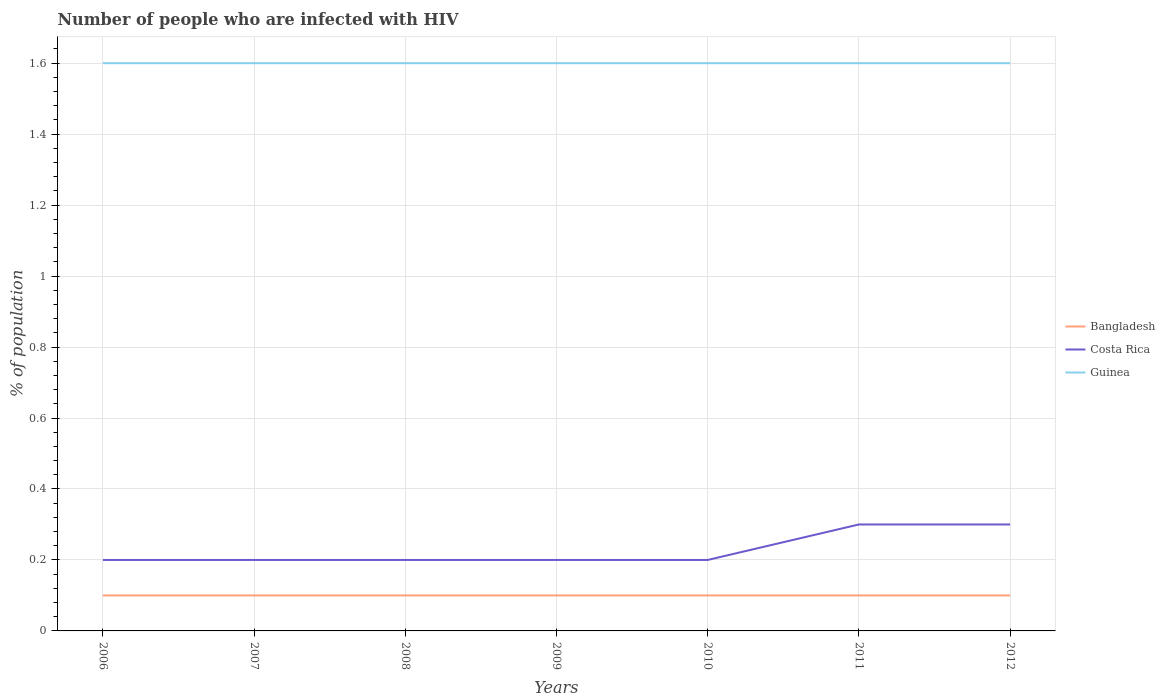How many different coloured lines are there?
Offer a terse response. 3. Across all years, what is the maximum percentage of HIV infected population in in Bangladesh?
Provide a succinct answer. 0.1. In which year was the percentage of HIV infected population in in Bangladesh maximum?
Your answer should be very brief. 2006. What is the difference between the highest and the lowest percentage of HIV infected population in in Bangladesh?
Your answer should be very brief. 7. How many lines are there?
Your answer should be very brief. 3. How many years are there in the graph?
Your response must be concise. 7. Does the graph contain any zero values?
Keep it short and to the point. No. Does the graph contain grids?
Your answer should be very brief. Yes. How many legend labels are there?
Ensure brevity in your answer.  3. What is the title of the graph?
Make the answer very short. Number of people who are infected with HIV. What is the label or title of the Y-axis?
Your answer should be very brief. % of population. What is the % of population of Bangladesh in 2006?
Make the answer very short. 0.1. What is the % of population of Costa Rica in 2006?
Make the answer very short. 0.2. What is the % of population of Guinea in 2006?
Your answer should be compact. 1.6. What is the % of population of Bangladesh in 2007?
Your response must be concise. 0.1. What is the % of population of Guinea in 2007?
Keep it short and to the point. 1.6. What is the % of population in Guinea in 2009?
Your response must be concise. 1.6. What is the % of population in Guinea in 2010?
Your answer should be very brief. 1.6. What is the % of population in Costa Rica in 2011?
Your answer should be compact. 0.3. Across all years, what is the maximum % of population in Costa Rica?
Provide a short and direct response. 0.3. Across all years, what is the maximum % of population of Guinea?
Provide a short and direct response. 1.6. Across all years, what is the minimum % of population in Bangladesh?
Keep it short and to the point. 0.1. Across all years, what is the minimum % of population in Guinea?
Your answer should be very brief. 1.6. What is the total % of population of Costa Rica in the graph?
Provide a short and direct response. 1.6. What is the difference between the % of population of Bangladesh in 2006 and that in 2007?
Ensure brevity in your answer.  0. What is the difference between the % of population of Bangladesh in 2006 and that in 2008?
Ensure brevity in your answer.  0. What is the difference between the % of population of Bangladesh in 2006 and that in 2009?
Provide a short and direct response. 0. What is the difference between the % of population of Guinea in 2006 and that in 2009?
Give a very brief answer. 0. What is the difference between the % of population in Bangladesh in 2006 and that in 2010?
Provide a succinct answer. 0. What is the difference between the % of population in Bangladesh in 2006 and that in 2011?
Ensure brevity in your answer.  0. What is the difference between the % of population in Bangladesh in 2006 and that in 2012?
Offer a terse response. 0. What is the difference between the % of population of Costa Rica in 2006 and that in 2012?
Keep it short and to the point. -0.1. What is the difference between the % of population in Costa Rica in 2007 and that in 2008?
Your answer should be very brief. 0. What is the difference between the % of population in Bangladesh in 2007 and that in 2009?
Your response must be concise. 0. What is the difference between the % of population of Costa Rica in 2007 and that in 2009?
Your response must be concise. 0. What is the difference between the % of population of Costa Rica in 2007 and that in 2010?
Your answer should be compact. 0. What is the difference between the % of population in Guinea in 2007 and that in 2010?
Offer a terse response. 0. What is the difference between the % of population of Bangladesh in 2007 and that in 2012?
Offer a terse response. 0. What is the difference between the % of population in Bangladesh in 2008 and that in 2009?
Your answer should be very brief. 0. What is the difference between the % of population in Costa Rica in 2008 and that in 2009?
Make the answer very short. 0. What is the difference between the % of population in Costa Rica in 2008 and that in 2010?
Give a very brief answer. 0. What is the difference between the % of population of Guinea in 2008 and that in 2010?
Make the answer very short. 0. What is the difference between the % of population of Costa Rica in 2008 and that in 2011?
Provide a short and direct response. -0.1. What is the difference between the % of population of Costa Rica in 2008 and that in 2012?
Your answer should be compact. -0.1. What is the difference between the % of population in Costa Rica in 2009 and that in 2010?
Make the answer very short. 0. What is the difference between the % of population of Guinea in 2009 and that in 2011?
Your response must be concise. 0. What is the difference between the % of population of Costa Rica in 2009 and that in 2012?
Your answer should be compact. -0.1. What is the difference between the % of population in Guinea in 2009 and that in 2012?
Your answer should be very brief. 0. What is the difference between the % of population of Bangladesh in 2010 and that in 2011?
Provide a succinct answer. 0. What is the difference between the % of population in Costa Rica in 2010 and that in 2011?
Offer a terse response. -0.1. What is the difference between the % of population of Bangladesh in 2010 and that in 2012?
Provide a short and direct response. 0. What is the difference between the % of population of Costa Rica in 2010 and that in 2012?
Provide a succinct answer. -0.1. What is the difference between the % of population of Bangladesh in 2011 and that in 2012?
Offer a very short reply. 0. What is the difference between the % of population of Costa Rica in 2011 and that in 2012?
Make the answer very short. 0. What is the difference between the % of population of Guinea in 2011 and that in 2012?
Make the answer very short. 0. What is the difference between the % of population in Bangladesh in 2006 and the % of population in Guinea in 2007?
Offer a terse response. -1.5. What is the difference between the % of population of Costa Rica in 2006 and the % of population of Guinea in 2007?
Give a very brief answer. -1.4. What is the difference between the % of population of Bangladesh in 2006 and the % of population of Guinea in 2008?
Your answer should be very brief. -1.5. What is the difference between the % of population in Costa Rica in 2006 and the % of population in Guinea in 2008?
Offer a very short reply. -1.4. What is the difference between the % of population in Bangladesh in 2006 and the % of population in Guinea in 2009?
Give a very brief answer. -1.5. What is the difference between the % of population in Bangladesh in 2006 and the % of population in Costa Rica in 2011?
Ensure brevity in your answer.  -0.2. What is the difference between the % of population of Bangladesh in 2006 and the % of population of Guinea in 2012?
Provide a short and direct response. -1.5. What is the difference between the % of population in Bangladesh in 2007 and the % of population in Guinea in 2008?
Make the answer very short. -1.5. What is the difference between the % of population of Costa Rica in 2007 and the % of population of Guinea in 2008?
Ensure brevity in your answer.  -1.4. What is the difference between the % of population in Bangladesh in 2007 and the % of population in Guinea in 2009?
Keep it short and to the point. -1.5. What is the difference between the % of population of Bangladesh in 2007 and the % of population of Costa Rica in 2010?
Keep it short and to the point. -0.1. What is the difference between the % of population of Bangladesh in 2007 and the % of population of Costa Rica in 2011?
Your answer should be very brief. -0.2. What is the difference between the % of population in Bangladesh in 2007 and the % of population in Guinea in 2011?
Your response must be concise. -1.5. What is the difference between the % of population of Costa Rica in 2007 and the % of population of Guinea in 2011?
Offer a very short reply. -1.4. What is the difference between the % of population of Bangladesh in 2007 and the % of population of Guinea in 2012?
Your response must be concise. -1.5. What is the difference between the % of population in Bangladesh in 2008 and the % of population in Guinea in 2009?
Offer a terse response. -1.5. What is the difference between the % of population of Costa Rica in 2008 and the % of population of Guinea in 2010?
Ensure brevity in your answer.  -1.4. What is the difference between the % of population of Bangladesh in 2008 and the % of population of Costa Rica in 2012?
Ensure brevity in your answer.  -0.2. What is the difference between the % of population of Costa Rica in 2008 and the % of population of Guinea in 2012?
Your answer should be compact. -1.4. What is the difference between the % of population in Costa Rica in 2009 and the % of population in Guinea in 2010?
Provide a succinct answer. -1.4. What is the difference between the % of population of Bangladesh in 2009 and the % of population of Guinea in 2011?
Give a very brief answer. -1.5. What is the difference between the % of population of Bangladesh in 2009 and the % of population of Costa Rica in 2012?
Your response must be concise. -0.2. What is the difference between the % of population of Bangladesh in 2009 and the % of population of Guinea in 2012?
Make the answer very short. -1.5. What is the difference between the % of population in Bangladesh in 2010 and the % of population in Costa Rica in 2011?
Offer a terse response. -0.2. What is the difference between the % of population in Bangladesh in 2010 and the % of population in Guinea in 2011?
Your answer should be very brief. -1.5. What is the difference between the % of population of Costa Rica in 2010 and the % of population of Guinea in 2011?
Give a very brief answer. -1.4. What is the difference between the % of population of Bangladesh in 2010 and the % of population of Costa Rica in 2012?
Your response must be concise. -0.2. What is the difference between the % of population in Costa Rica in 2010 and the % of population in Guinea in 2012?
Give a very brief answer. -1.4. What is the difference between the % of population in Bangladesh in 2011 and the % of population in Costa Rica in 2012?
Offer a terse response. -0.2. What is the difference between the % of population of Bangladesh in 2011 and the % of population of Guinea in 2012?
Your answer should be very brief. -1.5. What is the average % of population of Bangladesh per year?
Your answer should be compact. 0.1. What is the average % of population of Costa Rica per year?
Your response must be concise. 0.23. In the year 2006, what is the difference between the % of population of Bangladesh and % of population of Guinea?
Make the answer very short. -1.5. In the year 2007, what is the difference between the % of population of Bangladesh and % of population of Costa Rica?
Keep it short and to the point. -0.1. In the year 2007, what is the difference between the % of population in Bangladesh and % of population in Guinea?
Your answer should be compact. -1.5. In the year 2008, what is the difference between the % of population of Costa Rica and % of population of Guinea?
Keep it short and to the point. -1.4. In the year 2009, what is the difference between the % of population in Bangladesh and % of population in Guinea?
Provide a succinct answer. -1.5. In the year 2009, what is the difference between the % of population in Costa Rica and % of population in Guinea?
Make the answer very short. -1.4. In the year 2010, what is the difference between the % of population in Bangladesh and % of population in Guinea?
Provide a short and direct response. -1.5. In the year 2010, what is the difference between the % of population of Costa Rica and % of population of Guinea?
Your answer should be compact. -1.4. In the year 2011, what is the difference between the % of population of Bangladesh and % of population of Costa Rica?
Your answer should be very brief. -0.2. In the year 2011, what is the difference between the % of population of Bangladesh and % of population of Guinea?
Your answer should be very brief. -1.5. What is the ratio of the % of population of Bangladesh in 2006 to that in 2007?
Your answer should be very brief. 1. What is the ratio of the % of population in Costa Rica in 2006 to that in 2007?
Provide a succinct answer. 1. What is the ratio of the % of population in Guinea in 2006 to that in 2007?
Keep it short and to the point. 1. What is the ratio of the % of population of Guinea in 2006 to that in 2008?
Your answer should be compact. 1. What is the ratio of the % of population in Bangladesh in 2006 to that in 2009?
Ensure brevity in your answer.  1. What is the ratio of the % of population in Costa Rica in 2006 to that in 2012?
Provide a succinct answer. 0.67. What is the ratio of the % of population in Guinea in 2006 to that in 2012?
Offer a terse response. 1. What is the ratio of the % of population of Guinea in 2007 to that in 2008?
Your response must be concise. 1. What is the ratio of the % of population of Costa Rica in 2007 to that in 2010?
Keep it short and to the point. 1. What is the ratio of the % of population of Guinea in 2007 to that in 2010?
Offer a very short reply. 1. What is the ratio of the % of population of Bangladesh in 2007 to that in 2012?
Keep it short and to the point. 1. What is the ratio of the % of population in Bangladesh in 2008 to that in 2009?
Give a very brief answer. 1. What is the ratio of the % of population in Guinea in 2008 to that in 2009?
Make the answer very short. 1. What is the ratio of the % of population in Guinea in 2008 to that in 2010?
Your answer should be compact. 1. What is the ratio of the % of population in Costa Rica in 2008 to that in 2011?
Your response must be concise. 0.67. What is the ratio of the % of population of Costa Rica in 2008 to that in 2012?
Your answer should be very brief. 0.67. What is the ratio of the % of population in Bangladesh in 2009 to that in 2012?
Offer a very short reply. 1. What is the ratio of the % of population in Guinea in 2009 to that in 2012?
Ensure brevity in your answer.  1. What is the ratio of the % of population of Guinea in 2010 to that in 2011?
Keep it short and to the point. 1. What is the ratio of the % of population in Bangladesh in 2010 to that in 2012?
Give a very brief answer. 1. What is the ratio of the % of population in Costa Rica in 2010 to that in 2012?
Provide a short and direct response. 0.67. What is the ratio of the % of population in Bangladesh in 2011 to that in 2012?
Offer a very short reply. 1. What is the difference between the highest and the second highest % of population of Bangladesh?
Your response must be concise. 0. What is the difference between the highest and the second highest % of population in Guinea?
Give a very brief answer. 0. What is the difference between the highest and the lowest % of population of Costa Rica?
Your answer should be very brief. 0.1. 